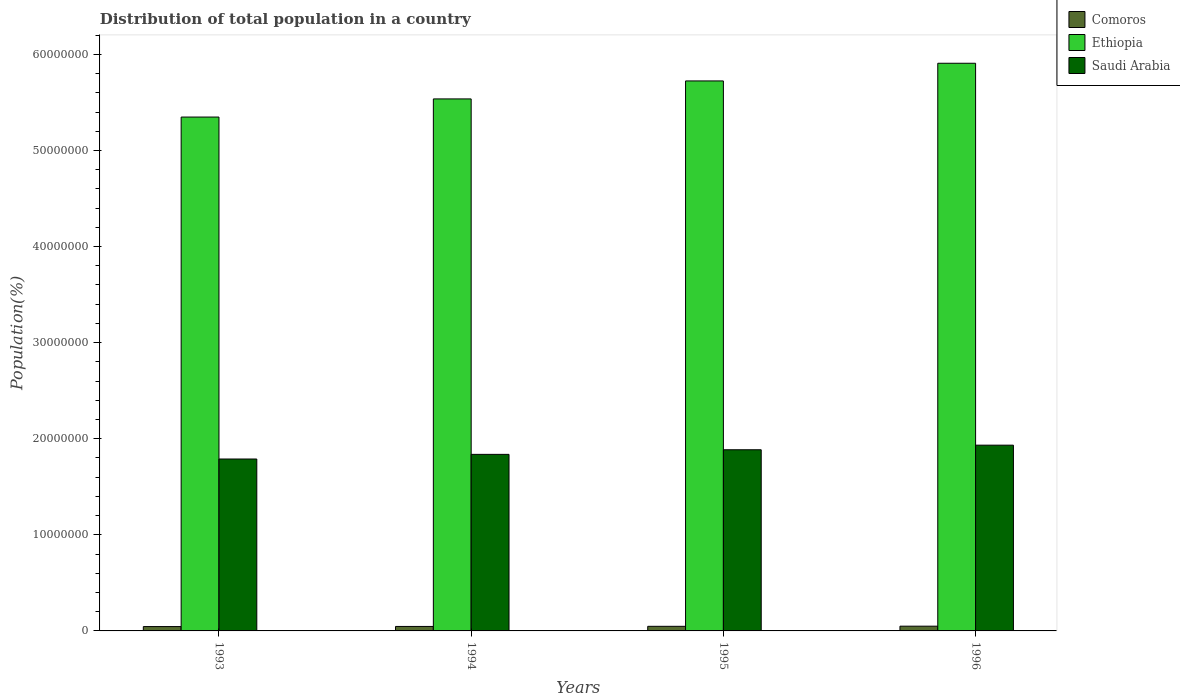How many different coloured bars are there?
Your answer should be very brief. 3. How many groups of bars are there?
Provide a short and direct response. 4. Are the number of bars on each tick of the X-axis equal?
Provide a succinct answer. Yes. How many bars are there on the 4th tick from the right?
Provide a short and direct response. 3. What is the population of in Ethiopia in 1994?
Ensure brevity in your answer.  5.54e+07. Across all years, what is the maximum population of in Ethiopia?
Give a very brief answer. 5.91e+07. Across all years, what is the minimum population of in Comoros?
Your answer should be very brief. 4.53e+05. In which year was the population of in Comoros maximum?
Your answer should be very brief. 1996. In which year was the population of in Comoros minimum?
Give a very brief answer. 1993. What is the total population of in Saudi Arabia in the graph?
Offer a very short reply. 7.44e+07. What is the difference between the population of in Comoros in 1993 and that in 1996?
Provide a succinct answer. -3.98e+04. What is the difference between the population of in Saudi Arabia in 1996 and the population of in Comoros in 1994?
Keep it short and to the point. 1.89e+07. What is the average population of in Saudi Arabia per year?
Your answer should be very brief. 1.86e+07. In the year 1996, what is the difference between the population of in Saudi Arabia and population of in Comoros?
Give a very brief answer. 1.88e+07. What is the ratio of the population of in Ethiopia in 1993 to that in 1995?
Make the answer very short. 0.93. Is the population of in Comoros in 1994 less than that in 1996?
Your answer should be very brief. Yes. Is the difference between the population of in Saudi Arabia in 1995 and 1996 greater than the difference between the population of in Comoros in 1995 and 1996?
Your answer should be compact. No. What is the difference between the highest and the second highest population of in Comoros?
Your response must be concise. 1.34e+04. What is the difference between the highest and the lowest population of in Saudi Arabia?
Make the answer very short. 1.44e+06. Is the sum of the population of in Saudi Arabia in 1993 and 1996 greater than the maximum population of in Ethiopia across all years?
Provide a succinct answer. No. What does the 2nd bar from the left in 1995 represents?
Make the answer very short. Ethiopia. What does the 3rd bar from the right in 1996 represents?
Ensure brevity in your answer.  Comoros. How many bars are there?
Provide a succinct answer. 12. Are all the bars in the graph horizontal?
Offer a terse response. No. How many years are there in the graph?
Offer a very short reply. 4. Are the values on the major ticks of Y-axis written in scientific E-notation?
Ensure brevity in your answer.  No. Does the graph contain grids?
Make the answer very short. No. How many legend labels are there?
Provide a succinct answer. 3. What is the title of the graph?
Offer a terse response. Distribution of total population in a country. Does "Papua New Guinea" appear as one of the legend labels in the graph?
Give a very brief answer. No. What is the label or title of the Y-axis?
Offer a terse response. Population(%). What is the Population(%) of Comoros in 1993?
Ensure brevity in your answer.  4.53e+05. What is the Population(%) of Ethiopia in 1993?
Your answer should be very brief. 5.35e+07. What is the Population(%) in Saudi Arabia in 1993?
Provide a succinct answer. 1.79e+07. What is the Population(%) in Comoros in 1994?
Provide a short and direct response. 4.66e+05. What is the Population(%) in Ethiopia in 1994?
Ensure brevity in your answer.  5.54e+07. What is the Population(%) in Saudi Arabia in 1994?
Your answer should be compact. 1.84e+07. What is the Population(%) of Comoros in 1995?
Offer a terse response. 4.80e+05. What is the Population(%) of Ethiopia in 1995?
Offer a very short reply. 5.72e+07. What is the Population(%) of Saudi Arabia in 1995?
Your answer should be very brief. 1.89e+07. What is the Population(%) in Comoros in 1996?
Provide a succinct answer. 4.93e+05. What is the Population(%) in Ethiopia in 1996?
Your answer should be very brief. 5.91e+07. What is the Population(%) of Saudi Arabia in 1996?
Your answer should be very brief. 1.93e+07. Across all years, what is the maximum Population(%) of Comoros?
Your answer should be very brief. 4.93e+05. Across all years, what is the maximum Population(%) in Ethiopia?
Provide a succinct answer. 5.91e+07. Across all years, what is the maximum Population(%) of Saudi Arabia?
Keep it short and to the point. 1.93e+07. Across all years, what is the minimum Population(%) of Comoros?
Provide a succinct answer. 4.53e+05. Across all years, what is the minimum Population(%) in Ethiopia?
Offer a very short reply. 5.35e+07. Across all years, what is the minimum Population(%) of Saudi Arabia?
Your answer should be very brief. 1.79e+07. What is the total Population(%) in Comoros in the graph?
Offer a very short reply. 1.89e+06. What is the total Population(%) in Ethiopia in the graph?
Your answer should be compact. 2.25e+08. What is the total Population(%) in Saudi Arabia in the graph?
Your response must be concise. 7.44e+07. What is the difference between the Population(%) in Comoros in 1993 and that in 1994?
Provide a succinct answer. -1.31e+04. What is the difference between the Population(%) of Ethiopia in 1993 and that in 1994?
Provide a short and direct response. -1.89e+06. What is the difference between the Population(%) in Saudi Arabia in 1993 and that in 1994?
Give a very brief answer. -4.83e+05. What is the difference between the Population(%) of Comoros in 1993 and that in 1995?
Make the answer very short. -2.64e+04. What is the difference between the Population(%) of Ethiopia in 1993 and that in 1995?
Your answer should be very brief. -3.76e+06. What is the difference between the Population(%) of Saudi Arabia in 1993 and that in 1995?
Offer a very short reply. -9.63e+05. What is the difference between the Population(%) of Comoros in 1993 and that in 1996?
Ensure brevity in your answer.  -3.98e+04. What is the difference between the Population(%) of Ethiopia in 1993 and that in 1996?
Give a very brief answer. -5.60e+06. What is the difference between the Population(%) of Saudi Arabia in 1993 and that in 1996?
Keep it short and to the point. -1.44e+06. What is the difference between the Population(%) of Comoros in 1994 and that in 1995?
Give a very brief answer. -1.33e+04. What is the difference between the Population(%) of Ethiopia in 1994 and that in 1995?
Ensure brevity in your answer.  -1.87e+06. What is the difference between the Population(%) in Saudi Arabia in 1994 and that in 1995?
Offer a very short reply. -4.80e+05. What is the difference between the Population(%) in Comoros in 1994 and that in 1996?
Give a very brief answer. -2.67e+04. What is the difference between the Population(%) in Ethiopia in 1994 and that in 1996?
Ensure brevity in your answer.  -3.71e+06. What is the difference between the Population(%) of Saudi Arabia in 1994 and that in 1996?
Offer a very short reply. -9.58e+05. What is the difference between the Population(%) in Comoros in 1995 and that in 1996?
Your answer should be very brief. -1.34e+04. What is the difference between the Population(%) of Ethiopia in 1995 and that in 1996?
Your response must be concise. -1.84e+06. What is the difference between the Population(%) in Saudi Arabia in 1995 and that in 1996?
Provide a short and direct response. -4.78e+05. What is the difference between the Population(%) in Comoros in 1993 and the Population(%) in Ethiopia in 1994?
Your answer should be very brief. -5.49e+07. What is the difference between the Population(%) of Comoros in 1993 and the Population(%) of Saudi Arabia in 1994?
Keep it short and to the point. -1.79e+07. What is the difference between the Population(%) of Ethiopia in 1993 and the Population(%) of Saudi Arabia in 1994?
Provide a succinct answer. 3.51e+07. What is the difference between the Population(%) in Comoros in 1993 and the Population(%) in Ethiopia in 1995?
Your answer should be compact. -5.68e+07. What is the difference between the Population(%) in Comoros in 1993 and the Population(%) in Saudi Arabia in 1995?
Your response must be concise. -1.84e+07. What is the difference between the Population(%) in Ethiopia in 1993 and the Population(%) in Saudi Arabia in 1995?
Provide a short and direct response. 3.46e+07. What is the difference between the Population(%) of Comoros in 1993 and the Population(%) of Ethiopia in 1996?
Offer a very short reply. -5.86e+07. What is the difference between the Population(%) in Comoros in 1993 and the Population(%) in Saudi Arabia in 1996?
Ensure brevity in your answer.  -1.89e+07. What is the difference between the Population(%) of Ethiopia in 1993 and the Population(%) of Saudi Arabia in 1996?
Provide a short and direct response. 3.41e+07. What is the difference between the Population(%) of Comoros in 1994 and the Population(%) of Ethiopia in 1995?
Offer a very short reply. -5.68e+07. What is the difference between the Population(%) of Comoros in 1994 and the Population(%) of Saudi Arabia in 1995?
Offer a very short reply. -1.84e+07. What is the difference between the Population(%) of Ethiopia in 1994 and the Population(%) of Saudi Arabia in 1995?
Provide a succinct answer. 3.65e+07. What is the difference between the Population(%) of Comoros in 1994 and the Population(%) of Ethiopia in 1996?
Make the answer very short. -5.86e+07. What is the difference between the Population(%) in Comoros in 1994 and the Population(%) in Saudi Arabia in 1996?
Provide a succinct answer. -1.89e+07. What is the difference between the Population(%) in Ethiopia in 1994 and the Population(%) in Saudi Arabia in 1996?
Your answer should be compact. 3.60e+07. What is the difference between the Population(%) in Comoros in 1995 and the Population(%) in Ethiopia in 1996?
Your answer should be very brief. -5.86e+07. What is the difference between the Population(%) in Comoros in 1995 and the Population(%) in Saudi Arabia in 1996?
Give a very brief answer. -1.89e+07. What is the difference between the Population(%) of Ethiopia in 1995 and the Population(%) of Saudi Arabia in 1996?
Offer a terse response. 3.79e+07. What is the average Population(%) in Comoros per year?
Offer a very short reply. 4.73e+05. What is the average Population(%) of Ethiopia per year?
Offer a terse response. 5.63e+07. What is the average Population(%) in Saudi Arabia per year?
Ensure brevity in your answer.  1.86e+07. In the year 1993, what is the difference between the Population(%) in Comoros and Population(%) in Ethiopia?
Provide a succinct answer. -5.30e+07. In the year 1993, what is the difference between the Population(%) of Comoros and Population(%) of Saudi Arabia?
Your answer should be very brief. -1.74e+07. In the year 1993, what is the difference between the Population(%) in Ethiopia and Population(%) in Saudi Arabia?
Offer a terse response. 3.56e+07. In the year 1994, what is the difference between the Population(%) of Comoros and Population(%) of Ethiopia?
Provide a succinct answer. -5.49e+07. In the year 1994, what is the difference between the Population(%) in Comoros and Population(%) in Saudi Arabia?
Keep it short and to the point. -1.79e+07. In the year 1994, what is the difference between the Population(%) of Ethiopia and Population(%) of Saudi Arabia?
Provide a succinct answer. 3.70e+07. In the year 1995, what is the difference between the Population(%) in Comoros and Population(%) in Ethiopia?
Give a very brief answer. -5.68e+07. In the year 1995, what is the difference between the Population(%) of Comoros and Population(%) of Saudi Arabia?
Offer a very short reply. -1.84e+07. In the year 1995, what is the difference between the Population(%) in Ethiopia and Population(%) in Saudi Arabia?
Provide a short and direct response. 3.84e+07. In the year 1996, what is the difference between the Population(%) in Comoros and Population(%) in Ethiopia?
Make the answer very short. -5.86e+07. In the year 1996, what is the difference between the Population(%) in Comoros and Population(%) in Saudi Arabia?
Keep it short and to the point. -1.88e+07. In the year 1996, what is the difference between the Population(%) in Ethiopia and Population(%) in Saudi Arabia?
Your answer should be compact. 3.97e+07. What is the ratio of the Population(%) of Comoros in 1993 to that in 1994?
Offer a very short reply. 0.97. What is the ratio of the Population(%) of Ethiopia in 1993 to that in 1994?
Keep it short and to the point. 0.97. What is the ratio of the Population(%) in Saudi Arabia in 1993 to that in 1994?
Offer a terse response. 0.97. What is the ratio of the Population(%) in Comoros in 1993 to that in 1995?
Your response must be concise. 0.94. What is the ratio of the Population(%) of Ethiopia in 1993 to that in 1995?
Ensure brevity in your answer.  0.93. What is the ratio of the Population(%) in Saudi Arabia in 1993 to that in 1995?
Your answer should be compact. 0.95. What is the ratio of the Population(%) in Comoros in 1993 to that in 1996?
Keep it short and to the point. 0.92. What is the ratio of the Population(%) of Ethiopia in 1993 to that in 1996?
Ensure brevity in your answer.  0.91. What is the ratio of the Population(%) of Saudi Arabia in 1993 to that in 1996?
Give a very brief answer. 0.93. What is the ratio of the Population(%) in Comoros in 1994 to that in 1995?
Offer a terse response. 0.97. What is the ratio of the Population(%) of Ethiopia in 1994 to that in 1995?
Offer a very short reply. 0.97. What is the ratio of the Population(%) of Saudi Arabia in 1994 to that in 1995?
Your answer should be very brief. 0.97. What is the ratio of the Population(%) of Comoros in 1994 to that in 1996?
Keep it short and to the point. 0.95. What is the ratio of the Population(%) in Ethiopia in 1994 to that in 1996?
Provide a succinct answer. 0.94. What is the ratio of the Population(%) of Saudi Arabia in 1994 to that in 1996?
Keep it short and to the point. 0.95. What is the ratio of the Population(%) in Comoros in 1995 to that in 1996?
Offer a terse response. 0.97. What is the ratio of the Population(%) in Ethiopia in 1995 to that in 1996?
Ensure brevity in your answer.  0.97. What is the ratio of the Population(%) of Saudi Arabia in 1995 to that in 1996?
Keep it short and to the point. 0.98. What is the difference between the highest and the second highest Population(%) in Comoros?
Your answer should be very brief. 1.34e+04. What is the difference between the highest and the second highest Population(%) in Ethiopia?
Provide a short and direct response. 1.84e+06. What is the difference between the highest and the second highest Population(%) in Saudi Arabia?
Ensure brevity in your answer.  4.78e+05. What is the difference between the highest and the lowest Population(%) in Comoros?
Your answer should be compact. 3.98e+04. What is the difference between the highest and the lowest Population(%) of Ethiopia?
Your answer should be very brief. 5.60e+06. What is the difference between the highest and the lowest Population(%) of Saudi Arabia?
Offer a terse response. 1.44e+06. 